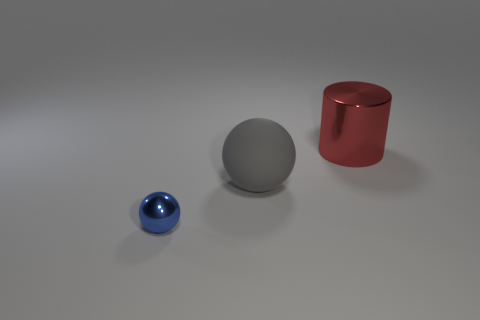There is a metal thing behind the metal object that is on the left side of the big cylinder; how many tiny blue balls are to the right of it? In the image, there is one small blue ball that is positioned to the left of the large sphere and to the left of the red cylinder as well. There are no blue balls to the right of the cylinder. It's sitting alone on the surface, slightly distanced from the other shapes, which include a larger gray sphere and a red cylinder. 